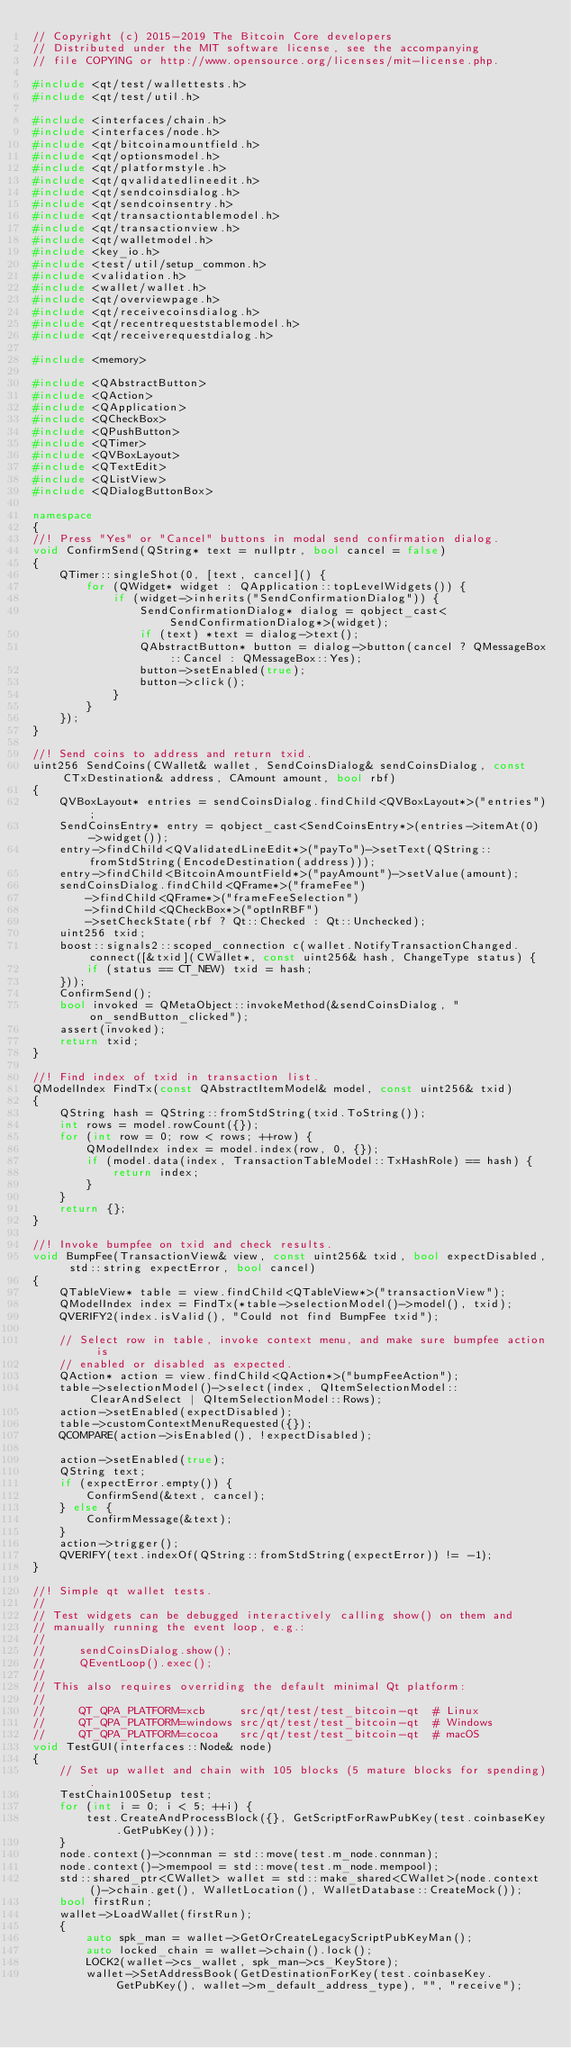<code> <loc_0><loc_0><loc_500><loc_500><_C++_>// Copyright (c) 2015-2019 The Bitcoin Core developers
// Distributed under the MIT software license, see the accompanying
// file COPYING or http://www.opensource.org/licenses/mit-license.php.

#include <qt/test/wallettests.h>
#include <qt/test/util.h>

#include <interfaces/chain.h>
#include <interfaces/node.h>
#include <qt/bitcoinamountfield.h>
#include <qt/optionsmodel.h>
#include <qt/platformstyle.h>
#include <qt/qvalidatedlineedit.h>
#include <qt/sendcoinsdialog.h>
#include <qt/sendcoinsentry.h>
#include <qt/transactiontablemodel.h>
#include <qt/transactionview.h>
#include <qt/walletmodel.h>
#include <key_io.h>
#include <test/util/setup_common.h>
#include <validation.h>
#include <wallet/wallet.h>
#include <qt/overviewpage.h>
#include <qt/receivecoinsdialog.h>
#include <qt/recentrequeststablemodel.h>
#include <qt/receiverequestdialog.h>

#include <memory>

#include <QAbstractButton>
#include <QAction>
#include <QApplication>
#include <QCheckBox>
#include <QPushButton>
#include <QTimer>
#include <QVBoxLayout>
#include <QTextEdit>
#include <QListView>
#include <QDialogButtonBox>

namespace
{
//! Press "Yes" or "Cancel" buttons in modal send confirmation dialog.
void ConfirmSend(QString* text = nullptr, bool cancel = false)
{
    QTimer::singleShot(0, [text, cancel]() {
        for (QWidget* widget : QApplication::topLevelWidgets()) {
            if (widget->inherits("SendConfirmationDialog")) {
                SendConfirmationDialog* dialog = qobject_cast<SendConfirmationDialog*>(widget);
                if (text) *text = dialog->text();
                QAbstractButton* button = dialog->button(cancel ? QMessageBox::Cancel : QMessageBox::Yes);
                button->setEnabled(true);
                button->click();
            }
        }
    });
}

//! Send coins to address and return txid.
uint256 SendCoins(CWallet& wallet, SendCoinsDialog& sendCoinsDialog, const CTxDestination& address, CAmount amount, bool rbf)
{
    QVBoxLayout* entries = sendCoinsDialog.findChild<QVBoxLayout*>("entries");
    SendCoinsEntry* entry = qobject_cast<SendCoinsEntry*>(entries->itemAt(0)->widget());
    entry->findChild<QValidatedLineEdit*>("payTo")->setText(QString::fromStdString(EncodeDestination(address)));
    entry->findChild<BitcoinAmountField*>("payAmount")->setValue(amount);
    sendCoinsDialog.findChild<QFrame*>("frameFee")
        ->findChild<QFrame*>("frameFeeSelection")
        ->findChild<QCheckBox*>("optInRBF")
        ->setCheckState(rbf ? Qt::Checked : Qt::Unchecked);
    uint256 txid;
    boost::signals2::scoped_connection c(wallet.NotifyTransactionChanged.connect([&txid](CWallet*, const uint256& hash, ChangeType status) {
        if (status == CT_NEW) txid = hash;
    }));
    ConfirmSend();
    bool invoked = QMetaObject::invokeMethod(&sendCoinsDialog, "on_sendButton_clicked");
    assert(invoked);
    return txid;
}

//! Find index of txid in transaction list.
QModelIndex FindTx(const QAbstractItemModel& model, const uint256& txid)
{
    QString hash = QString::fromStdString(txid.ToString());
    int rows = model.rowCount({});
    for (int row = 0; row < rows; ++row) {
        QModelIndex index = model.index(row, 0, {});
        if (model.data(index, TransactionTableModel::TxHashRole) == hash) {
            return index;
        }
    }
    return {};
}

//! Invoke bumpfee on txid and check results.
void BumpFee(TransactionView& view, const uint256& txid, bool expectDisabled, std::string expectError, bool cancel)
{
    QTableView* table = view.findChild<QTableView*>("transactionView");
    QModelIndex index = FindTx(*table->selectionModel()->model(), txid);
    QVERIFY2(index.isValid(), "Could not find BumpFee txid");

    // Select row in table, invoke context menu, and make sure bumpfee action is
    // enabled or disabled as expected.
    QAction* action = view.findChild<QAction*>("bumpFeeAction");
    table->selectionModel()->select(index, QItemSelectionModel::ClearAndSelect | QItemSelectionModel::Rows);
    action->setEnabled(expectDisabled);
    table->customContextMenuRequested({});
    QCOMPARE(action->isEnabled(), !expectDisabled);

    action->setEnabled(true);
    QString text;
    if (expectError.empty()) {
        ConfirmSend(&text, cancel);
    } else {
        ConfirmMessage(&text);
    }
    action->trigger();
    QVERIFY(text.indexOf(QString::fromStdString(expectError)) != -1);
}

//! Simple qt wallet tests.
//
// Test widgets can be debugged interactively calling show() on them and
// manually running the event loop, e.g.:
//
//     sendCoinsDialog.show();
//     QEventLoop().exec();
//
// This also requires overriding the default minimal Qt platform:
//
//     QT_QPA_PLATFORM=xcb     src/qt/test/test_bitcoin-qt  # Linux
//     QT_QPA_PLATFORM=windows src/qt/test/test_bitcoin-qt  # Windows
//     QT_QPA_PLATFORM=cocoa   src/qt/test/test_bitcoin-qt  # macOS
void TestGUI(interfaces::Node& node)
{
    // Set up wallet and chain with 105 blocks (5 mature blocks for spending).
    TestChain100Setup test;
    for (int i = 0; i < 5; ++i) {
        test.CreateAndProcessBlock({}, GetScriptForRawPubKey(test.coinbaseKey.GetPubKey()));
    }
    node.context()->connman = std::move(test.m_node.connman);
    node.context()->mempool = std::move(test.m_node.mempool);
    std::shared_ptr<CWallet> wallet = std::make_shared<CWallet>(node.context()->chain.get(), WalletLocation(), WalletDatabase::CreateMock());
    bool firstRun;
    wallet->LoadWallet(firstRun);
    {
        auto spk_man = wallet->GetOrCreateLegacyScriptPubKeyMan();
        auto locked_chain = wallet->chain().lock();
        LOCK2(wallet->cs_wallet, spk_man->cs_KeyStore);
        wallet->SetAddressBook(GetDestinationForKey(test.coinbaseKey.GetPubKey(), wallet->m_default_address_type), "", "receive");</code> 